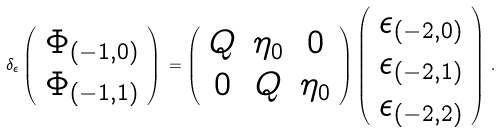<formula> <loc_0><loc_0><loc_500><loc_500>\delta _ { \epsilon } \left ( \begin{array} { c } \Phi _ { ( - 1 , 0 ) } \\ \Phi _ { ( - 1 , 1 ) } \end{array} \right ) \, = \left ( \begin{array} { c c c } Q & \eta _ { 0 } & 0 \\ 0 & Q & \eta _ { 0 } \end{array} \right ) \left ( \begin{array} { c } \epsilon _ { ( - 2 , 0 ) } \\ \epsilon _ { ( - 2 , 1 ) } \\ \epsilon _ { ( - 2 , 2 ) } \end{array} \right ) \, .</formula> 